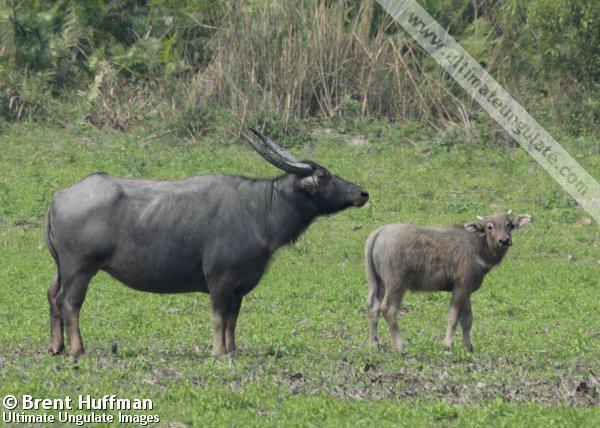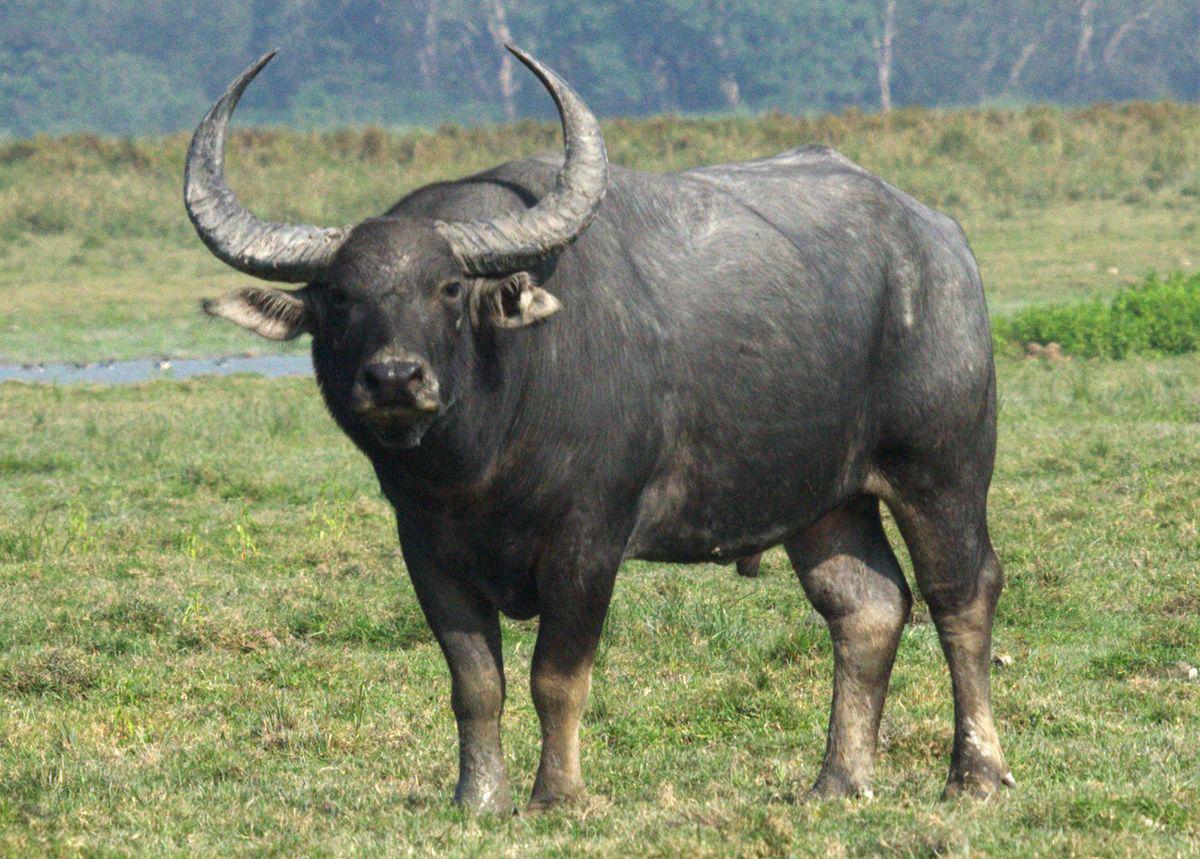The first image is the image on the left, the second image is the image on the right. Given the left and right images, does the statement "An image shows a water buffalo standing in water." hold true? Answer yes or no. No. The first image is the image on the left, the second image is the image on the right. Considering the images on both sides, is "A water buffalo is standing in water." valid? Answer yes or no. No. 